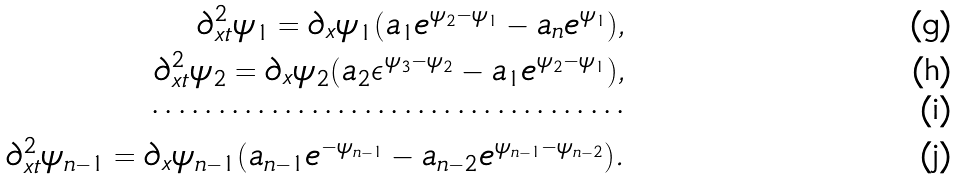Convert formula to latex. <formula><loc_0><loc_0><loc_500><loc_500>\partial ^ { 2 } _ { x t } \psi _ { 1 } = \partial _ { x } \psi _ { 1 } ( a _ { 1 } e ^ { \psi _ { 2 } - \psi _ { 1 } } - a _ { n } e ^ { \psi _ { 1 } } ) , \\ \partial ^ { 2 } _ { x t } \psi _ { 2 } = \partial _ { x } \psi _ { 2 } ( a _ { 2 } \epsilon ^ { \psi _ { 3 } - \psi _ { 2 } } - a _ { 1 } e ^ { \psi _ { 2 } - \psi _ { 1 } } ) , \\ \cdots \cdots \cdots \cdots \cdots \cdots \cdots \cdots \cdots \cdots \cdots \cdots \\ \partial ^ { 2 } _ { x t } \psi _ { n - 1 } = \partial _ { x } \psi _ { n - 1 } ( a _ { n - 1 } e ^ { - \psi _ { n - 1 } } - a _ { n - 2 } e ^ { \psi _ { n - 1 } - \psi _ { n - 2 } } ) .</formula> 